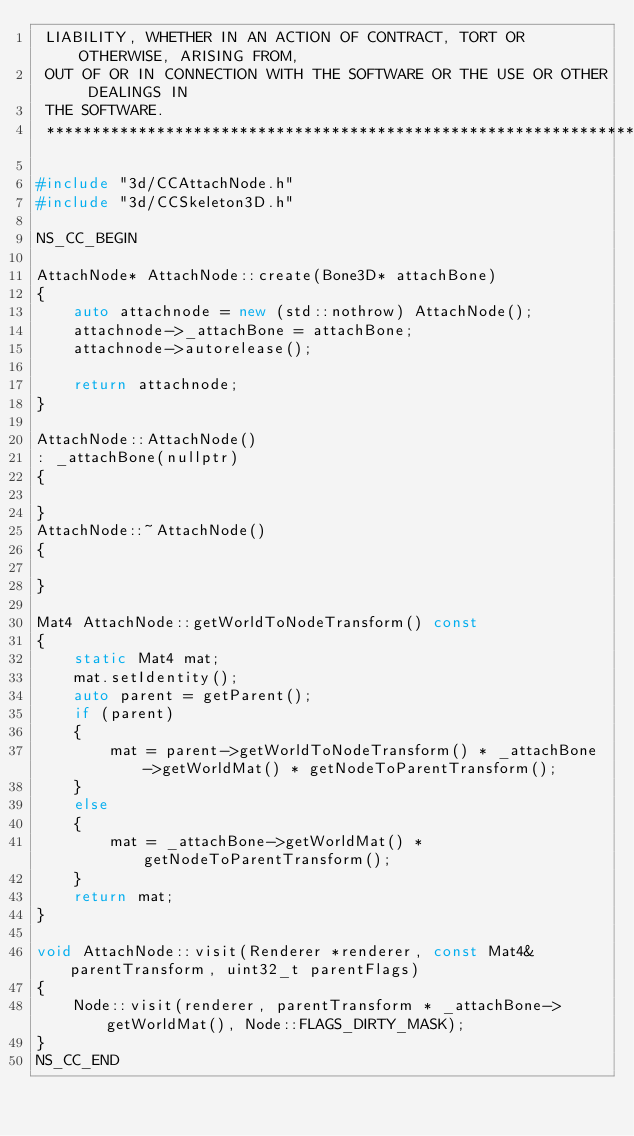Convert code to text. <code><loc_0><loc_0><loc_500><loc_500><_C++_> LIABILITY, WHETHER IN AN ACTION OF CONTRACT, TORT OR OTHERWISE, ARISING FROM,
 OUT OF OR IN CONNECTION WITH THE SOFTWARE OR THE USE OR OTHER DEALINGS IN
 THE SOFTWARE.
 ****************************************************************************/

#include "3d/CCAttachNode.h"
#include "3d/CCSkeleton3D.h"

NS_CC_BEGIN

AttachNode* AttachNode::create(Bone3D* attachBone)
{
    auto attachnode = new (std::nothrow) AttachNode();
    attachnode->_attachBone = attachBone;
    attachnode->autorelease();
    
    return attachnode;
}

AttachNode::AttachNode()
: _attachBone(nullptr)
{
    
}
AttachNode::~AttachNode()
{
    
}

Mat4 AttachNode::getWorldToNodeTransform() const
{
    static Mat4 mat;
    mat.setIdentity();
    auto parent = getParent();
    if (parent)
    {
        mat = parent->getWorldToNodeTransform() * _attachBone->getWorldMat() * getNodeToParentTransform();
    }
    else
    {
        mat = _attachBone->getWorldMat() * getNodeToParentTransform();
    }
    return mat;
}

void AttachNode::visit(Renderer *renderer, const Mat4& parentTransform, uint32_t parentFlags)
{
    Node::visit(renderer, parentTransform * _attachBone->getWorldMat(), Node::FLAGS_DIRTY_MASK);
}
NS_CC_END

</code> 